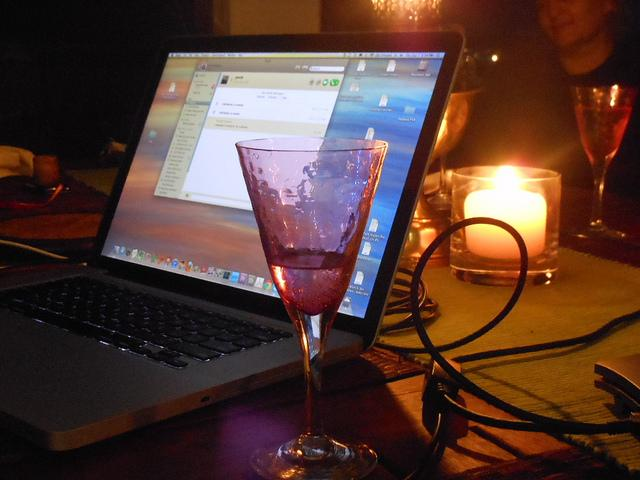What country most frequently uses wine glasses this shape? Please explain your reasoning. france. This glass is used greatly in france. 